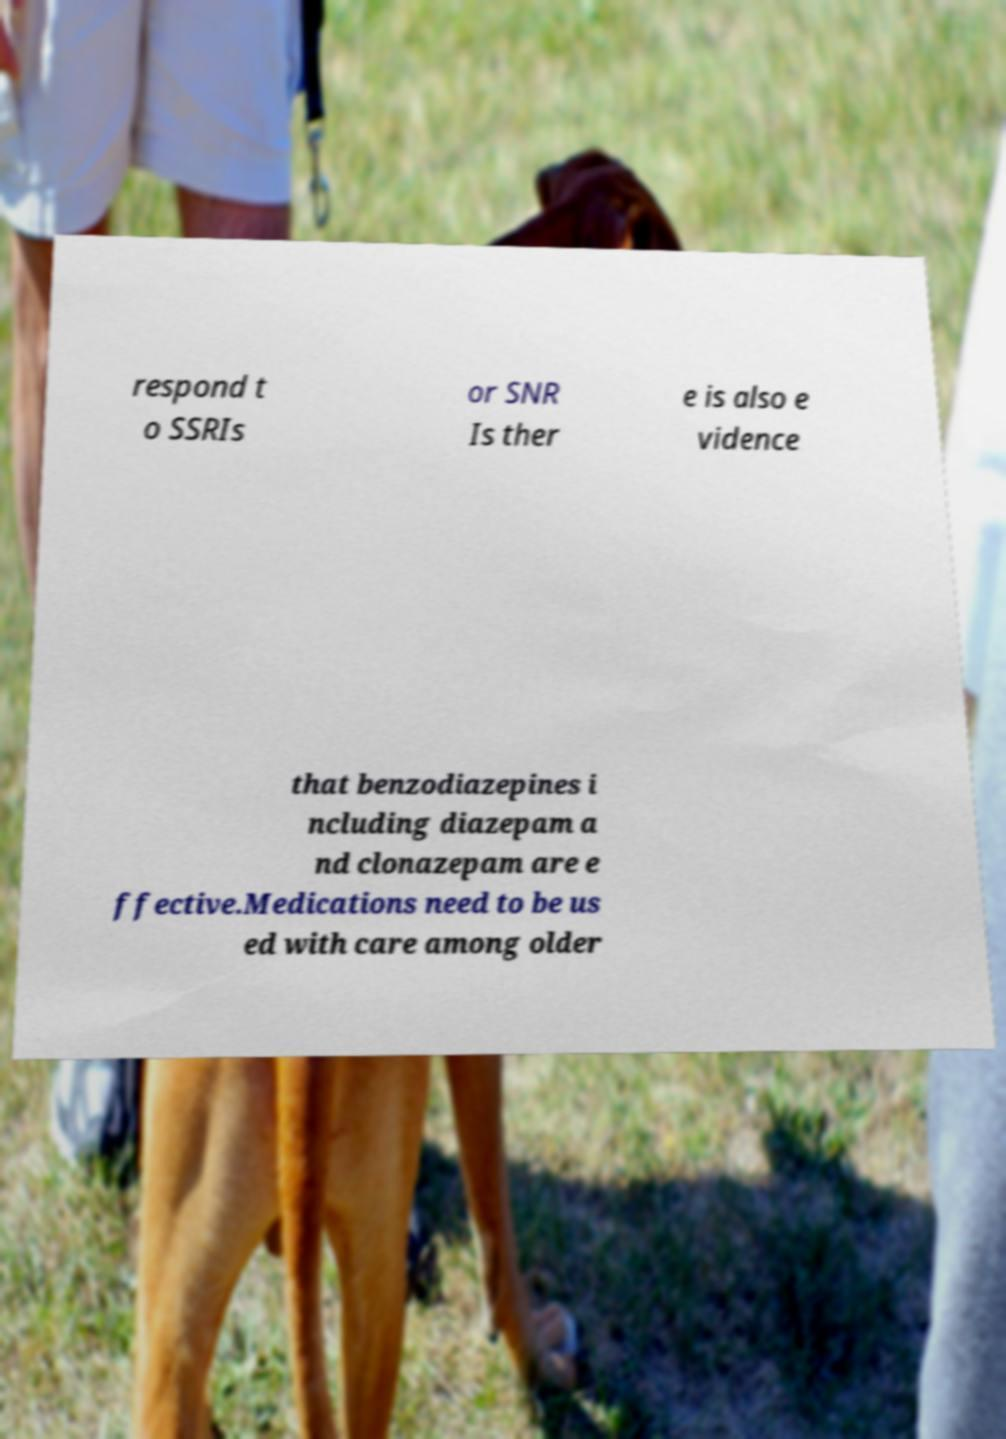I need the written content from this picture converted into text. Can you do that? respond t o SSRIs or SNR Is ther e is also e vidence that benzodiazepines i ncluding diazepam a nd clonazepam are e ffective.Medications need to be us ed with care among older 